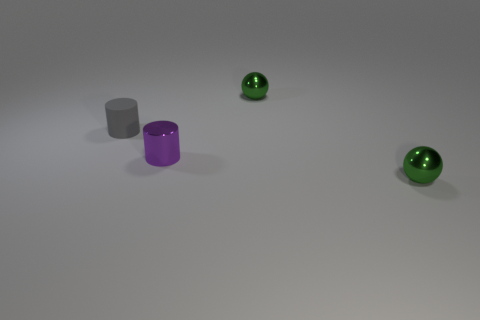What materials could the objects in the image represent in real life? The matte gray cylinder might represent a piece of chalk or a stone pillar, while the metallic purple cylinder could be reminiscent of a colored metal vase or anodized aluminum tube. The green spherical objects may suggest glass marbles or polished jade stones. 